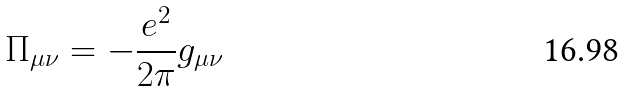<formula> <loc_0><loc_0><loc_500><loc_500>\Pi _ { \mu \nu } = - \frac { e ^ { 2 } } { 2 \pi } g _ { \mu \nu }</formula> 